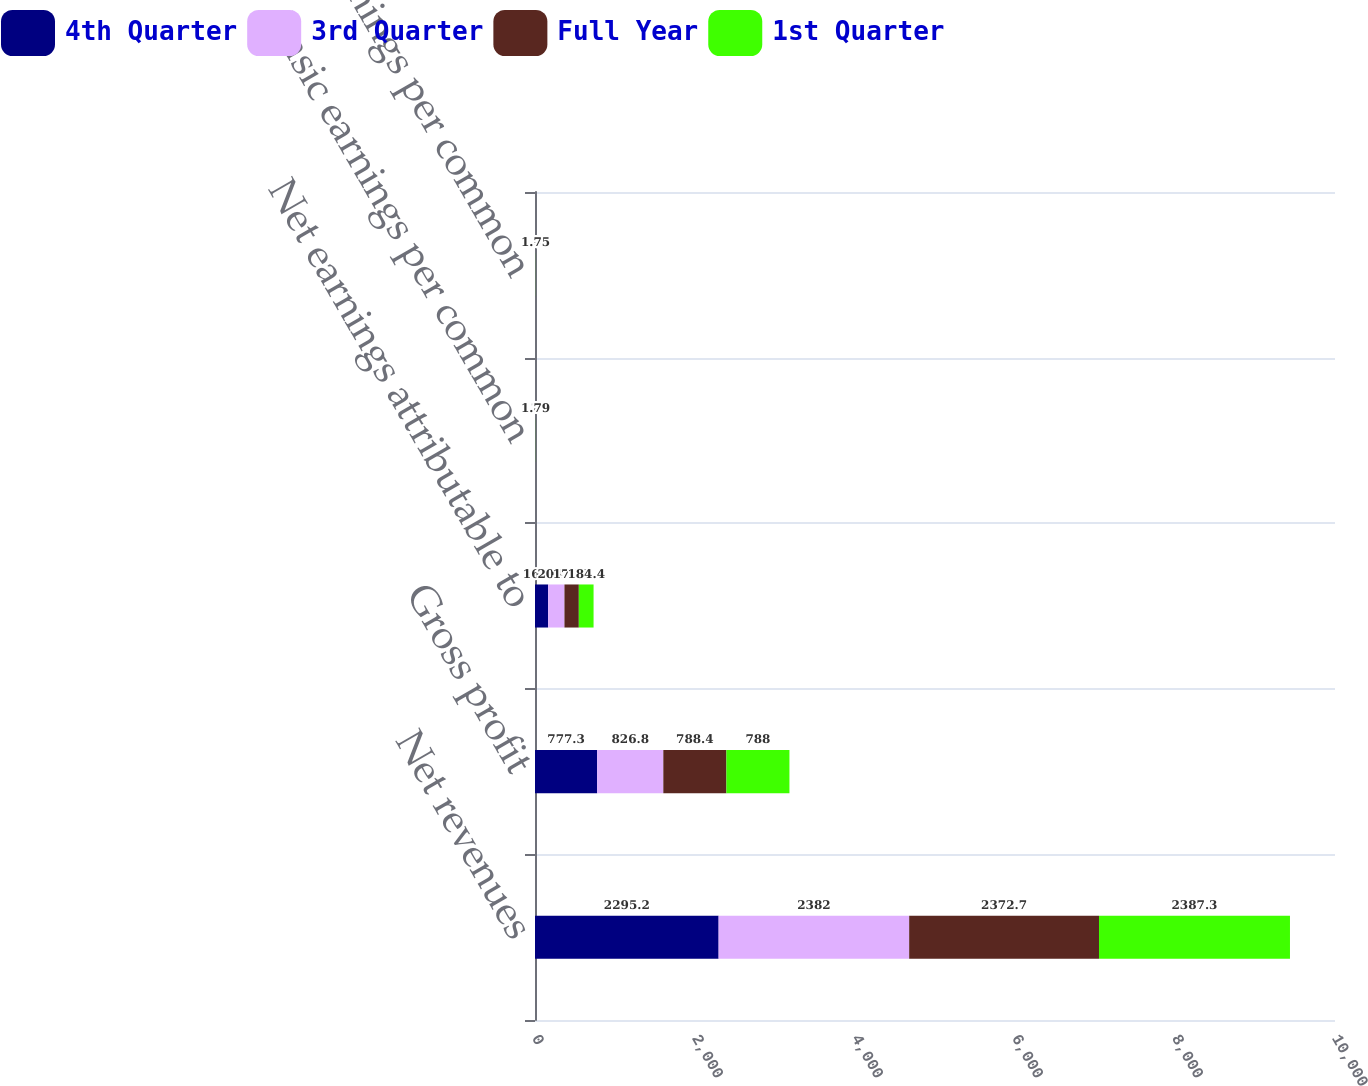<chart> <loc_0><loc_0><loc_500><loc_500><stacked_bar_chart><ecel><fcel>Net revenues<fcel>Gross profit<fcel>Net earnings attributable to<fcel>Basic earnings per common<fcel>Diluted earnings per common<nl><fcel>4th Quarter<fcel>2295.2<fcel>777.3<fcel>164.1<fcel>1.61<fcel>1.58<nl><fcel>3rd Quarter<fcel>2382<fcel>826.8<fcel>204.1<fcel>2<fcel>1.96<nl><fcel>Full Year<fcel>2372.7<fcel>788.4<fcel>179.5<fcel>1.74<fcel>1.71<nl><fcel>1st Quarter<fcel>2387.3<fcel>788<fcel>184.4<fcel>1.79<fcel>1.75<nl></chart> 